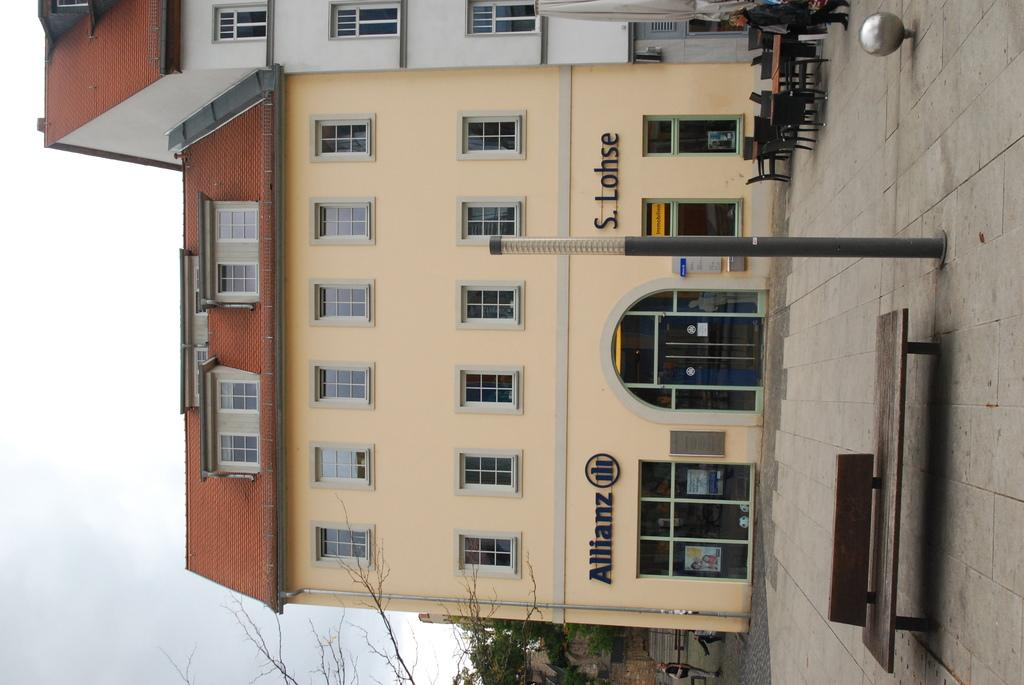<image>
Provide a brief description of the given image. Outside of a building with the words "allianz" on the front. 